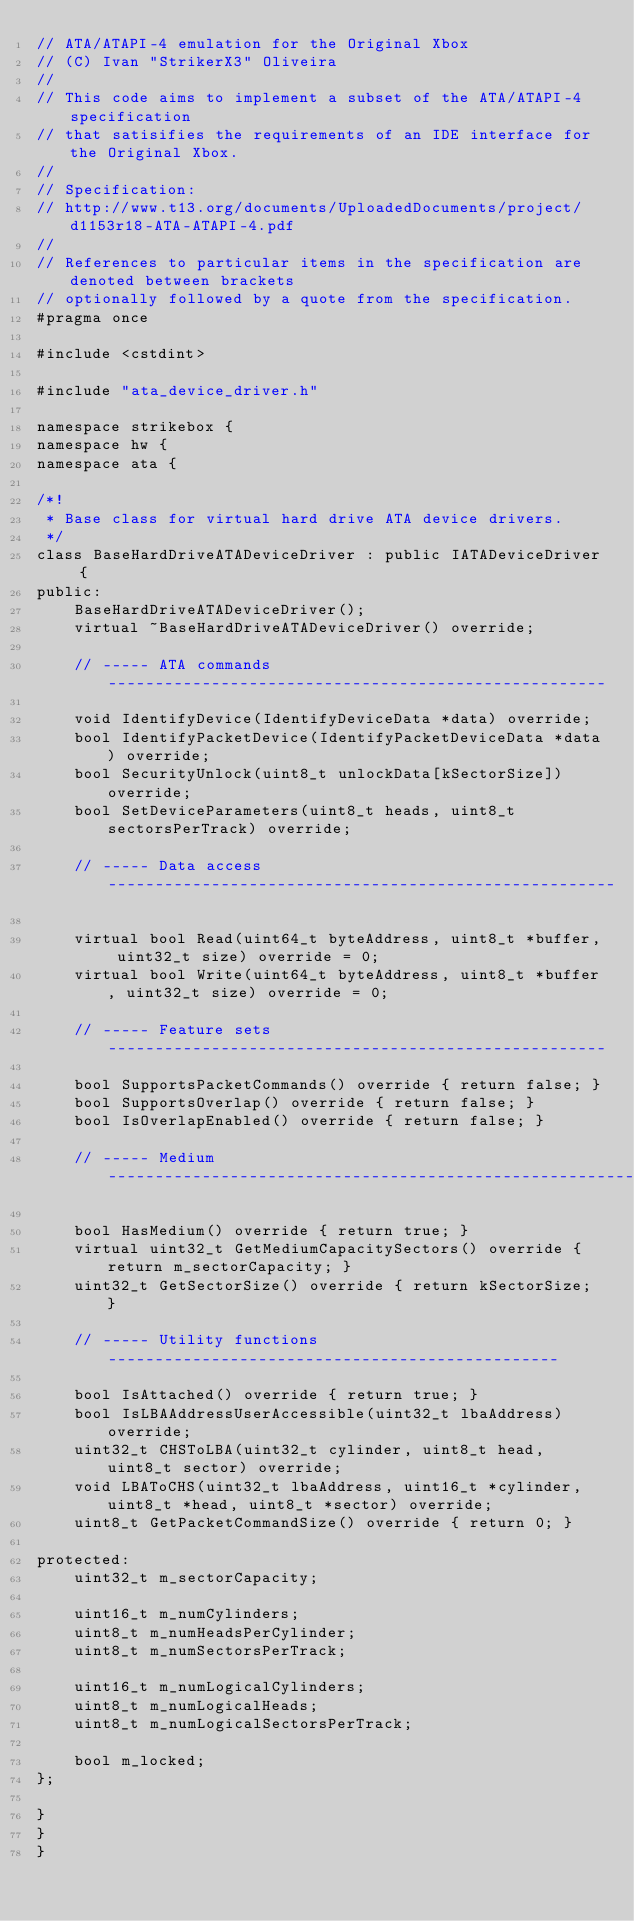<code> <loc_0><loc_0><loc_500><loc_500><_C_>// ATA/ATAPI-4 emulation for the Original Xbox
// (C) Ivan "StrikerX3" Oliveira
//
// This code aims to implement a subset of the ATA/ATAPI-4 specification
// that satisifies the requirements of an IDE interface for the Original Xbox.
//
// Specification:
// http://www.t13.org/documents/UploadedDocuments/project/d1153r18-ATA-ATAPI-4.pdf
//
// References to particular items in the specification are denoted between brackets
// optionally followed by a quote from the specification.
#pragma once

#include <cstdint>

#include "ata_device_driver.h"

namespace strikebox {
namespace hw {
namespace ata {

/*!
 * Base class for virtual hard drive ATA device drivers.
 */
class BaseHardDriveATADeviceDriver : public IATADeviceDriver {
public:
    BaseHardDriveATADeviceDriver();
    virtual ~BaseHardDriveATADeviceDriver() override;

    // ----- ATA commands -----------------------------------------------------

    void IdentifyDevice(IdentifyDeviceData *data) override;
    bool IdentifyPacketDevice(IdentifyPacketDeviceData *data) override;
    bool SecurityUnlock(uint8_t unlockData[kSectorSize]) override;
    bool SetDeviceParameters(uint8_t heads, uint8_t sectorsPerTrack) override;

    // ----- Data access ------------------------------------------------------
    
    virtual bool Read(uint64_t byteAddress, uint8_t *buffer, uint32_t size) override = 0;
    virtual bool Write(uint64_t byteAddress, uint8_t *buffer, uint32_t size) override = 0;

    // ----- Feature sets -----------------------------------------------------

    bool SupportsPacketCommands() override { return false; }
    bool SupportsOverlap() override { return false; }
    bool IsOverlapEnabled() override { return false; }

    // ----- Medium -----------------------------------------------------------

    bool HasMedium() override { return true; }
    virtual uint32_t GetMediumCapacitySectors() override { return m_sectorCapacity; }
    uint32_t GetSectorSize() override { return kSectorSize; }

    // ----- Utility functions ------------------------------------------------
    
    bool IsAttached() override { return true; }
    bool IsLBAAddressUserAccessible(uint32_t lbaAddress) override;
    uint32_t CHSToLBA(uint32_t cylinder, uint8_t head, uint8_t sector) override;
    void LBAToCHS(uint32_t lbaAddress, uint16_t *cylinder, uint8_t *head, uint8_t *sector) override;
    uint8_t GetPacketCommandSize() override { return 0; }

protected:
    uint32_t m_sectorCapacity;

    uint16_t m_numCylinders;
    uint8_t m_numHeadsPerCylinder;
    uint8_t m_numSectorsPerTrack;

    uint16_t m_numLogicalCylinders;
    uint8_t m_numLogicalHeads;
    uint8_t m_numLogicalSectorsPerTrack;

    bool m_locked;
};

}
}
}
</code> 